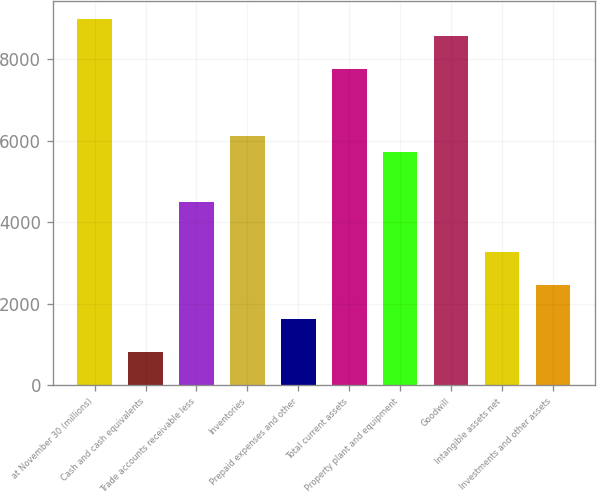Convert chart to OTSL. <chart><loc_0><loc_0><loc_500><loc_500><bar_chart><fcel>at November 30 (millions)<fcel>Cash and cash equivalents<fcel>Trade accounts receivable less<fcel>Inventories<fcel>Prepaid expenses and other<fcel>Total current assets<fcel>Property plant and equipment<fcel>Goodwill<fcel>Intangible assets net<fcel>Investments and other assets<nl><fcel>8986.68<fcel>821.88<fcel>4496.04<fcel>6129<fcel>1638.36<fcel>7761.96<fcel>5720.76<fcel>8578.44<fcel>3271.32<fcel>2454.84<nl></chart> 